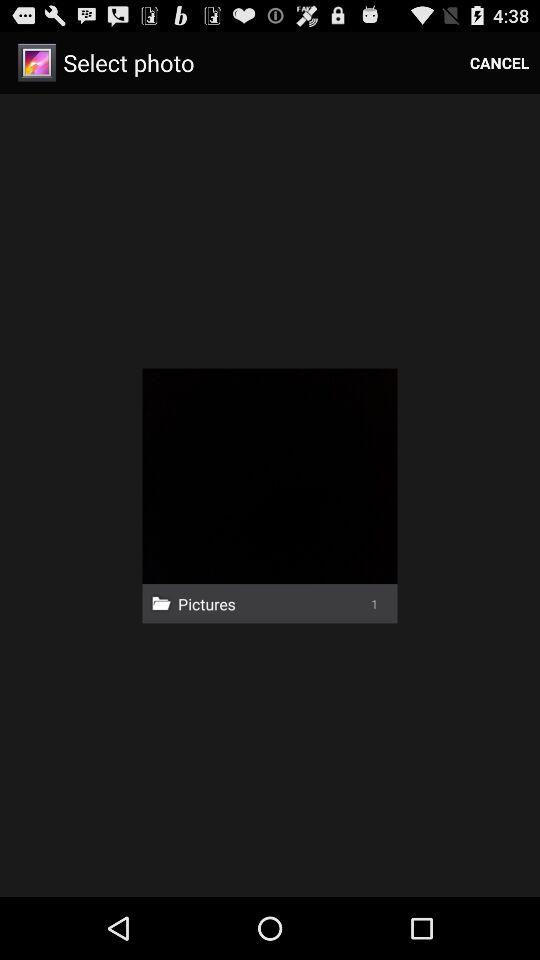How many images are there in the "Pictures" folder? There is 1 image. 